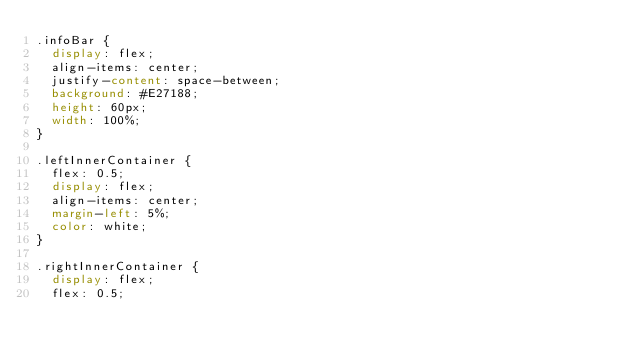<code> <loc_0><loc_0><loc_500><loc_500><_CSS_>.infoBar {
  display: flex;
  align-items: center;
  justify-content: space-between;
  background: #E27188;
  height: 60px;
  width: 100%;
}

.leftInnerContainer {
  flex: 0.5;
  display: flex;
  align-items: center;
  margin-left: 5%;
  color: white;
}

.rightInnerContainer {
  display: flex;
  flex: 0.5;</code> 